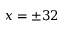<formula> <loc_0><loc_0><loc_500><loc_500>x = \pm 3 2</formula> 